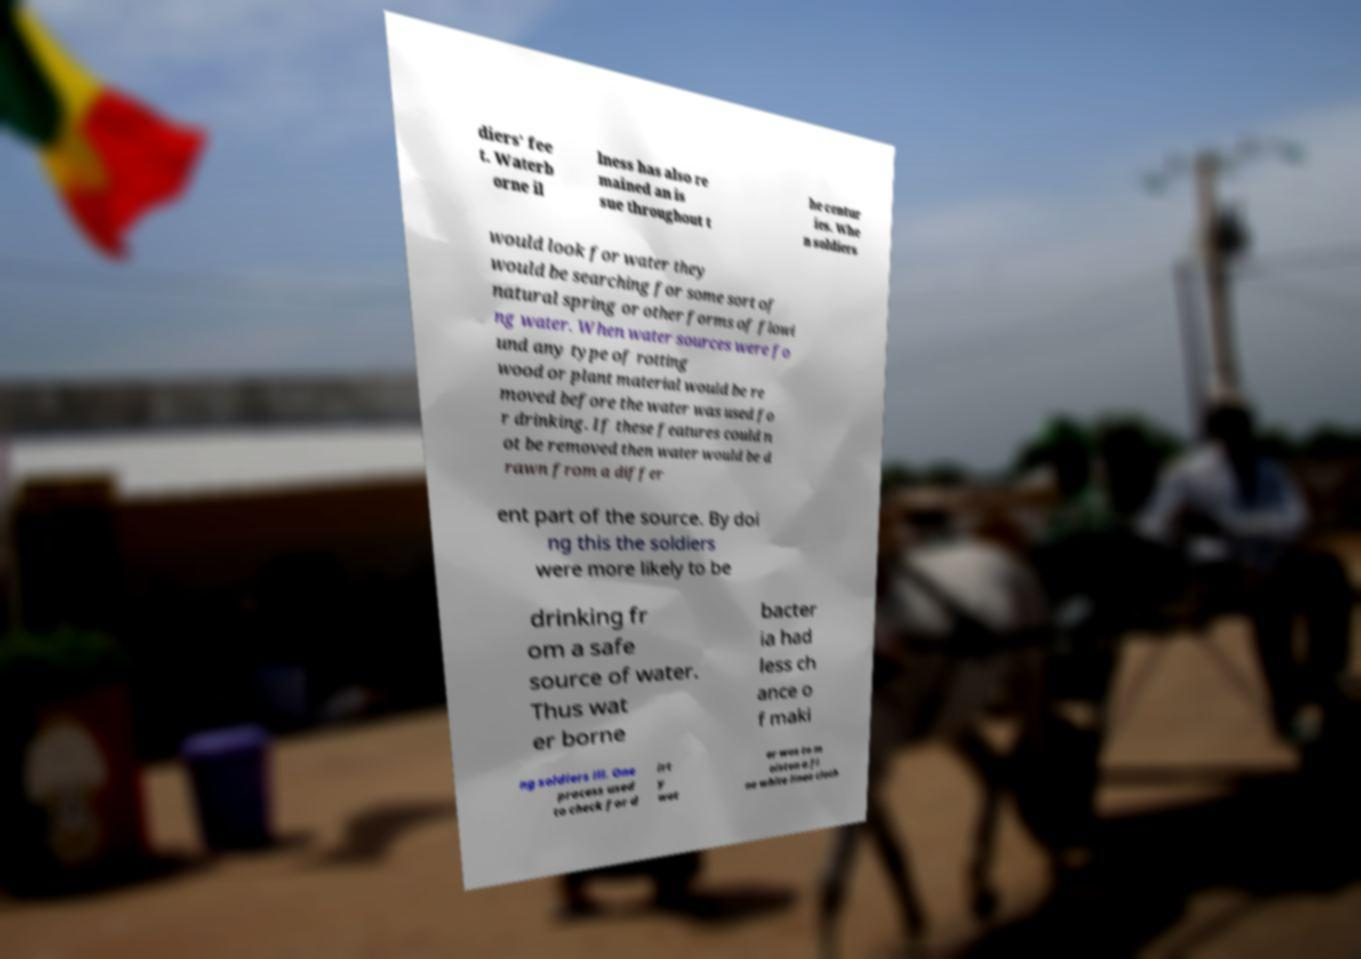Could you extract and type out the text from this image? diers’ fee t. Waterb orne il lness has also re mained an is sue throughout t he centur ies. Whe n soldiers would look for water they would be searching for some sort of natural spring or other forms of flowi ng water. When water sources were fo und any type of rotting wood or plant material would be re moved before the water was used fo r drinking. If these features could n ot be removed then water would be d rawn from a differ ent part of the source. By doi ng this the soldiers were more likely to be drinking fr om a safe source of water. Thus wat er borne bacter ia had less ch ance o f maki ng soldiers ill. One process used to check for d irt y wat er was to m oisten a fi ne white linen cloth 